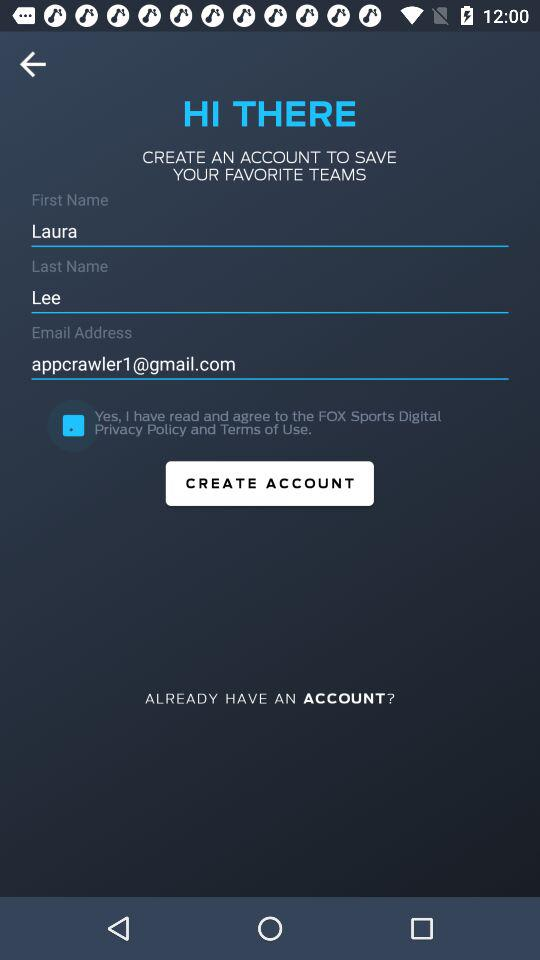What is the last name? The last name is Lee. 